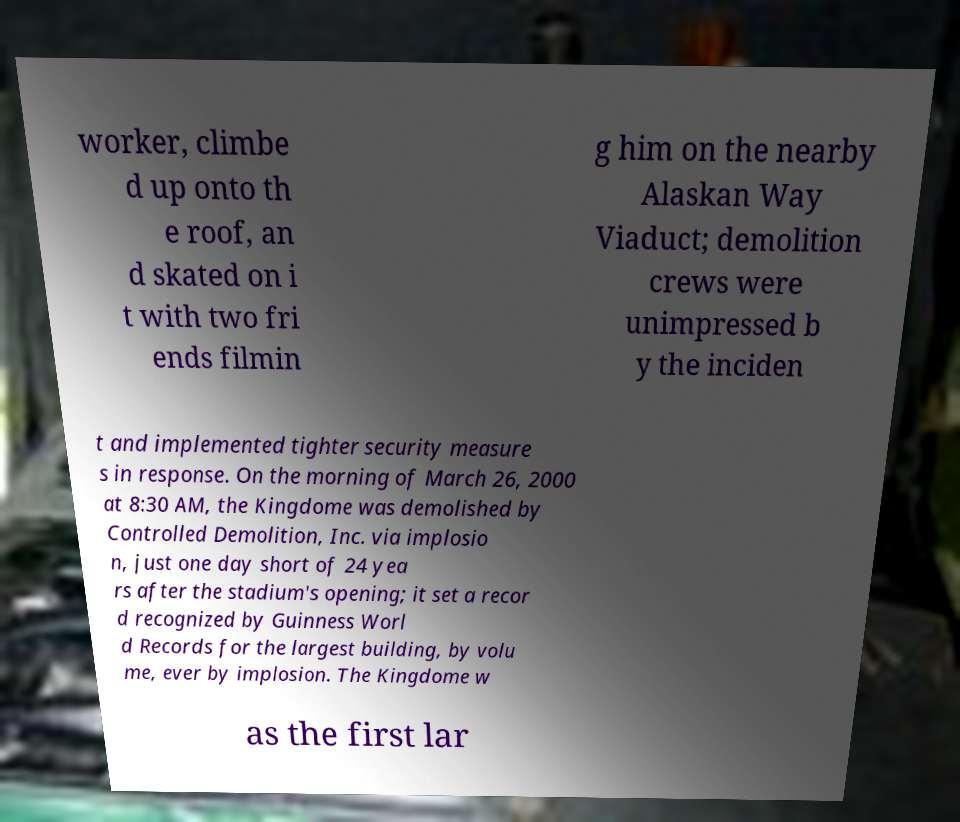Could you assist in decoding the text presented in this image and type it out clearly? worker, climbe d up onto th e roof, an d skated on i t with two fri ends filmin g him on the nearby Alaskan Way Viaduct; demolition crews were unimpressed b y the inciden t and implemented tighter security measure s in response. On the morning of March 26, 2000 at 8:30 AM, the Kingdome was demolished by Controlled Demolition, Inc. via implosio n, just one day short of 24 yea rs after the stadium's opening; it set a recor d recognized by Guinness Worl d Records for the largest building, by volu me, ever by implosion. The Kingdome w as the first lar 